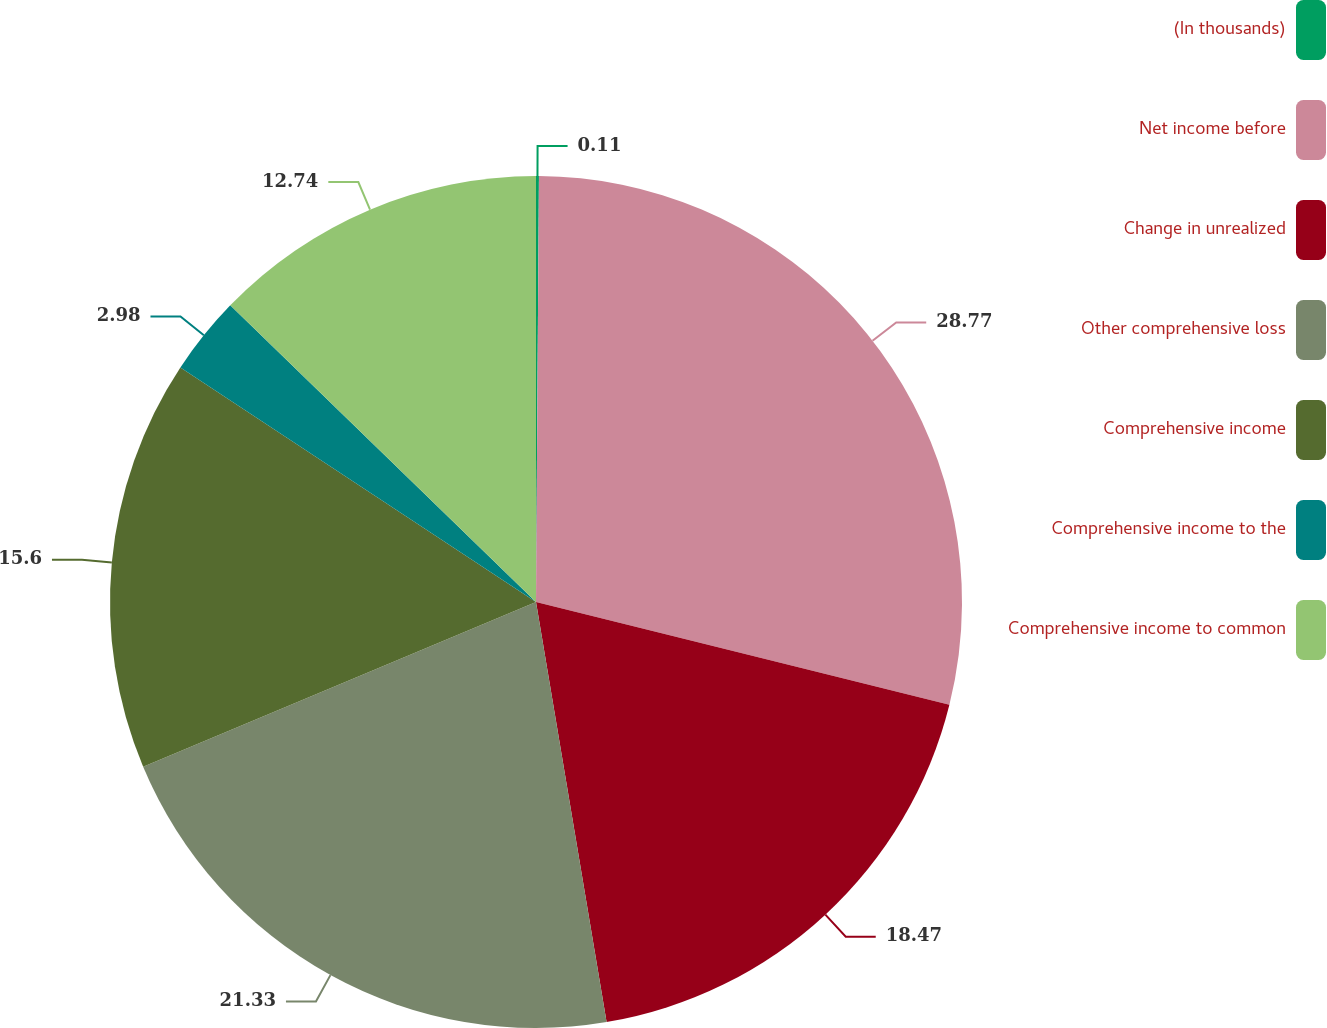Convert chart to OTSL. <chart><loc_0><loc_0><loc_500><loc_500><pie_chart><fcel>(In thousands)<fcel>Net income before<fcel>Change in unrealized<fcel>Other comprehensive loss<fcel>Comprehensive income<fcel>Comprehensive income to the<fcel>Comprehensive income to common<nl><fcel>0.11%<fcel>28.77%<fcel>18.47%<fcel>21.33%<fcel>15.6%<fcel>2.98%<fcel>12.74%<nl></chart> 